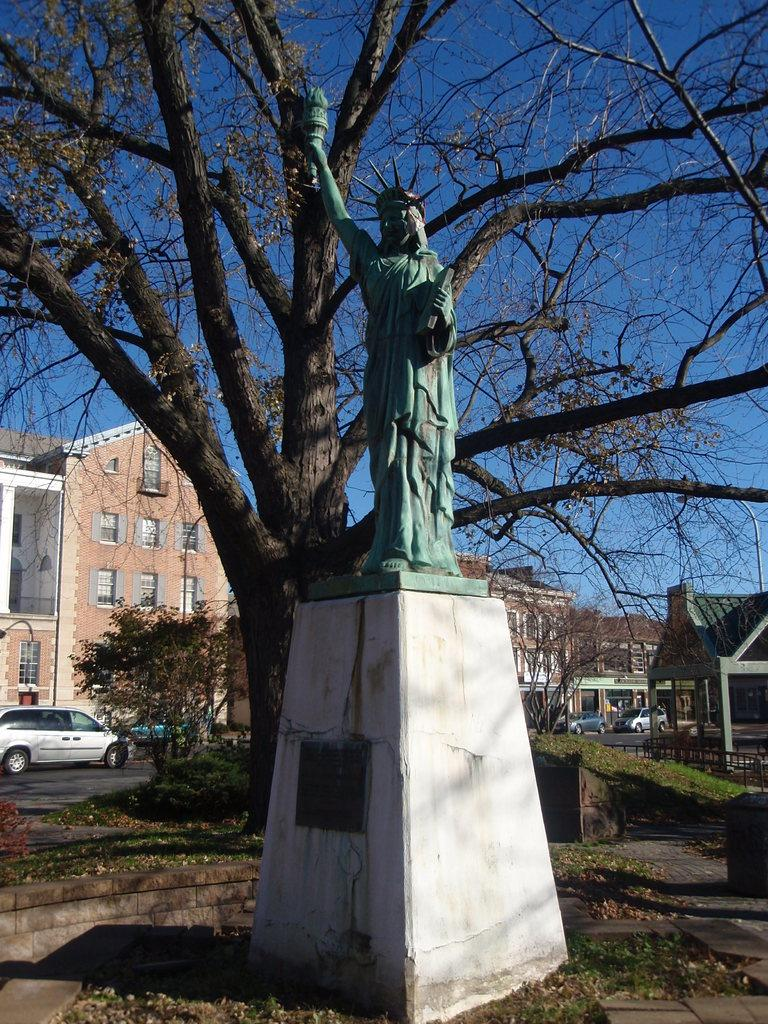What is the main subject in the image? There is a statue in the image. What type of natural elements can be seen in the image? There are trees in the image. What type of man-made structures are present in the image? There are buildings in the image. What type of vehicles can be seen in the image? There are cars in the image. What is the color of the sky in the image? The sky is blue in the image. What type of muscle can be seen on the statue in the image? The statue is not a living being and therefore does not have muscles. --- 